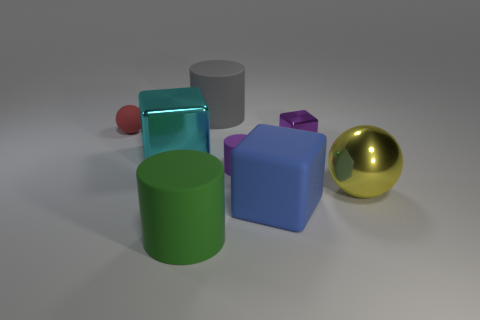Subtract all metallic cubes. How many cubes are left? 1 Add 2 purple blocks. How many objects exist? 10 Subtract all cyan cubes. How many cubes are left? 2 Subtract 0 brown cylinders. How many objects are left? 8 Subtract all spheres. How many objects are left? 6 Subtract 1 balls. How many balls are left? 1 Subtract all purple cubes. Subtract all purple cylinders. How many cubes are left? 2 Subtract all cyan balls. How many purple blocks are left? 1 Subtract all green metallic spheres. Subtract all red rubber spheres. How many objects are left? 7 Add 6 cyan blocks. How many cyan blocks are left? 7 